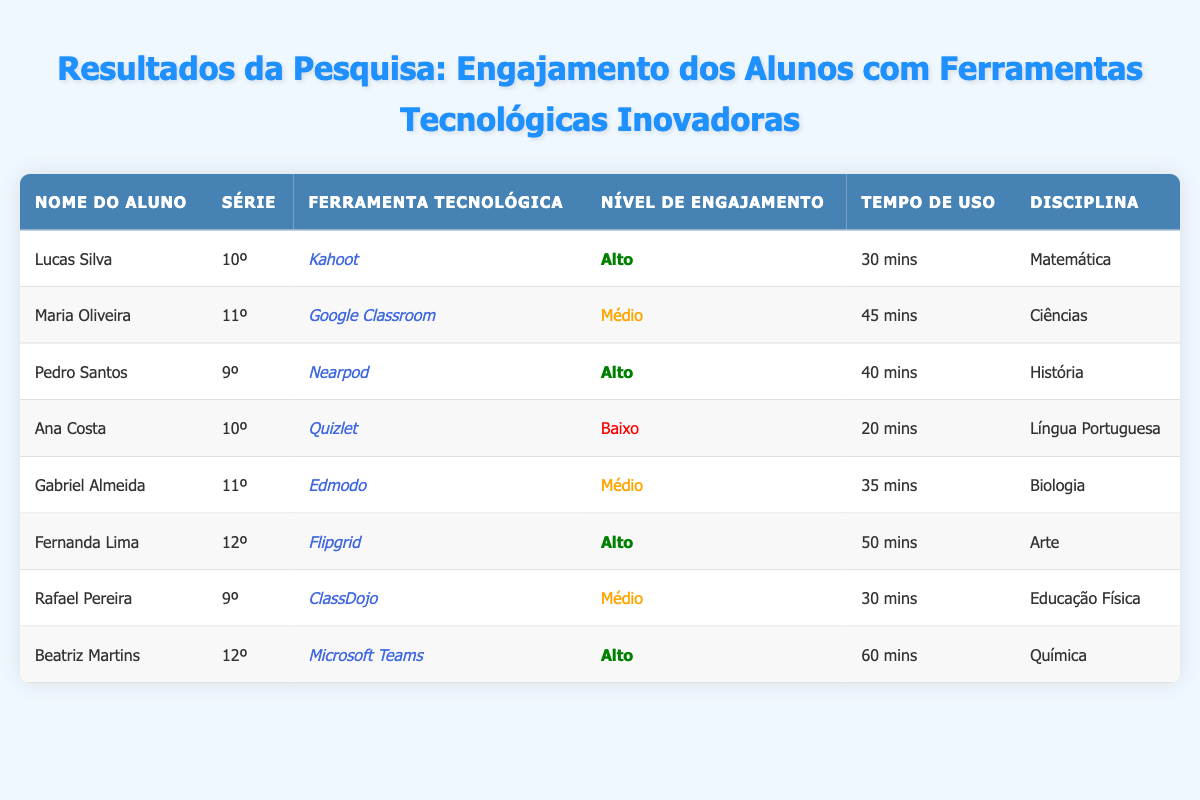What technology tool did Lucas Silva use? Lucas Silva is listed in the table, and under the "Ferramenta Tecnológica" column, it states he used "Kahoot."
Answer: Kahoot How much time did Fernanda Lima spend using Flipgrid? In the row for Fernanda Lima, the "Tempo de Uso" column indicates she spent "50 mins" using Flipgrid.
Answer: 50 mins Which student had a low engagement level? By reviewing the "Nível de Engajamento" column, Ana Costa is identified with a low engagement level marked as "Baixo."
Answer: Ana Costa How many students reported a high engagement level? The table shows three students with a high engagement level: Lucas Silva, Pedro Santos, and Fernanda Lima.
Answer: 3 What is the average time spent using technology tools for students with high engagement levels? The students with high engagement (Lucas Silva, Pedro Santos, Fernanda Lima, Beatriz Martins) spent 30 mins, 40 mins, 50 mins, and 60 mins respectively. Summing these gives 30 + 40 + 50 + 60 = 180 mins. Dividing by 4 (number of students), the average is 180 / 4 = 45 mins.
Answer: 45 mins Did any students spend more than 60 minutes using a tech tool? By checking the "Tempo de Uso" column, none of the students listed spent more than 60 minutes; the highest recorded is Beatriz Martins with 60 mins.
Answer: No Which tech tool was associated with the highest engagement level? The students who reported high engagement used Kahoot, Nearpod, Flipgrid, and Microsoft Teams. Among these, Kahoot and Flipgrid are specifically mentioned.
Answer: Kahoot and Flipgrid Is there any student from 9th grade using a technology tool with medium engagement? Rafael Pereira from the 9th grade is indicated in the table with a medium engagement level for the tech tool ClassDojo, confirming that at least one student fits this criterion.
Answer: Yes 